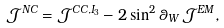Convert formula to latex. <formula><loc_0><loc_0><loc_500><loc_500>\mathcal { J } ^ { N C } = \mathcal { J } ^ { C C , I _ { 3 } } - 2 \sin ^ { 2 } \theta _ { W } \, \mathcal { J } ^ { E M } ,</formula> 